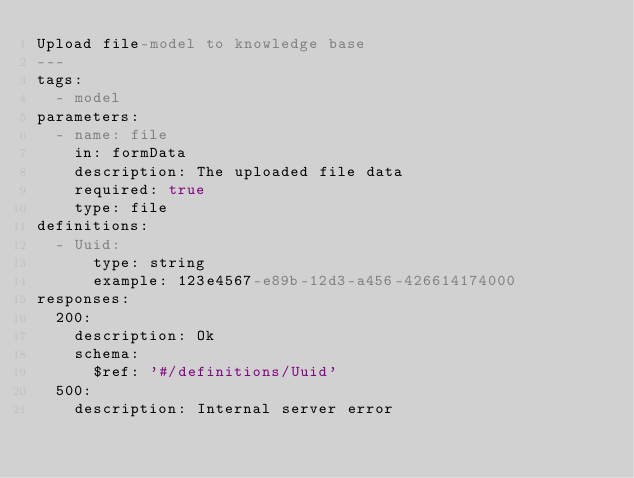<code> <loc_0><loc_0><loc_500><loc_500><_YAML_>Upload file-model to knowledge base
---
tags:
  - model
parameters:
  - name: file
    in: formData
    description: The uploaded file data
    required: true
    type: file
definitions:
  - Uuid:
      type: string
      example: 123e4567-e89b-12d3-a456-426614174000
responses:
  200:
    description: Ok
    schema:
      $ref: '#/definitions/Uuid'
  500:
    description: Internal server error
</code> 